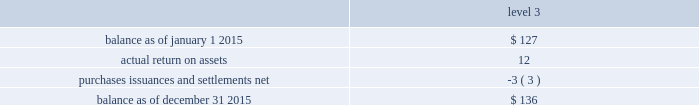The tables present a reconciliation of the beginning and ending balances of the fair value measurements using significant unobservable inputs ( level 3 ) for 2015 and 2014 , respectively: .
Purchases , issuances and settlements , net .
76 balance as of december 31 , 2014 .
$ 127 the company 2019s other postretirement benefit plans are partially funded and the assets are held under various trusts .
The investments and risk mitigation strategies for the plans are tailored specifically for each trust .
In setting new strategic asset mixes , consideration is given to the likelihood that the selected asset allocation will effectively fund the projected plan liabilities and the risk tolerance of the company .
The company periodically updates the long-term , strategic asset allocations and uses various analytics to determine the optimal asset allocation .
Considerations include plan liability characteristics , liquidity characteristics , funding requirements , expected rates of return and the distribution of returns .
In june 2012 , the company implemented a de-risking strategy for the medical bargaining trust within the plan to minimize volatility .
As part of the de-risking strategy , the company revised the asset allocations to increase the matching characteristics of assets relative to liabilities .
The initial de-risking asset allocation for the plan was 60% ( 60 % ) return-generating assets and 40% ( 40 % ) liability-driven assets .
The investment strategies and policies for the plan reflect a balance of liability driven and return-generating considerations .
The objective of minimizing the volatility of assets relative to liabilities is addressed primarily through asset 2014liability matching , asset diversification and hedging .
The fixed income target asset allocation matches the bond-like and long-dated nature of the postretirement liabilities .
Assets are broadly diversified within asset classes to achieve risk-adjusted returns that in total lower asset volatility relative to the liabilities .
The company assesses the investment strategy regularly to ensure actual allocations are in line with target allocations as appropriate .
Strategies to address the goal of ensuring sufficient assets to pay benefits include target allocations to a broad array of asset classes and , within asset classes strategies are employed to provide adequate returns , diversification and liquidity .
The assets of the company 2019s other trusts , within the other postretirement benefit plans , have been primarily invested in equities and fixed income funds .
The assets under the various other postretirement benefit trusts are invested differently based on the assets and liabilities of each trust .
The obligations of the other postretirement benefit plans are dominated by obligations for the medical bargaining trust .
Thirty-nine percent and four percent of the total postretirement plan benefit obligations are related to the medical non-bargaining and life insurance trusts , respectively .
Because expected benefit payments related to the benefit obligations are so far into the future , and the size of the medical non-bargaining and life insurance trusts 2019 obligations are large compared to each trusts 2019 assets , the investment strategy is to allocate a significant portion of the assets 2019 investment to equities , which the company believes will provide the highest long-term return and improve the funding ratio .
The company engages third party investment managers for all invested assets .
Managers are not permitted to invest outside of the asset class ( e.g .
Fixed income , equity , alternatives ) or strategy for which they have been appointed .
Investment management agreements and recurring performance and attribution analysis are used as tools to ensure investment managers invest solely within the investment strategy they have been provided .
Futures and options may be used to adjust portfolio duration to align with a plan 2019s targeted investment policy. .
What was the growth rate in the account balance 2015? 
Rationale: the growth rate of the account balance is the change from the begin to the end dividing the result by the begin balance
Computations: ((12 + -3) / 127)
Answer: 0.07087. The tables present a reconciliation of the beginning and ending balances of the fair value measurements using significant unobservable inputs ( level 3 ) for 2015 and 2014 , respectively: .
Purchases , issuances and settlements , net .
76 balance as of december 31 , 2014 .
$ 127 the company 2019s other postretirement benefit plans are partially funded and the assets are held under various trusts .
The investments and risk mitigation strategies for the plans are tailored specifically for each trust .
In setting new strategic asset mixes , consideration is given to the likelihood that the selected asset allocation will effectively fund the projected plan liabilities and the risk tolerance of the company .
The company periodically updates the long-term , strategic asset allocations and uses various analytics to determine the optimal asset allocation .
Considerations include plan liability characteristics , liquidity characteristics , funding requirements , expected rates of return and the distribution of returns .
In june 2012 , the company implemented a de-risking strategy for the medical bargaining trust within the plan to minimize volatility .
As part of the de-risking strategy , the company revised the asset allocations to increase the matching characteristics of assets relative to liabilities .
The initial de-risking asset allocation for the plan was 60% ( 60 % ) return-generating assets and 40% ( 40 % ) liability-driven assets .
The investment strategies and policies for the plan reflect a balance of liability driven and return-generating considerations .
The objective of minimizing the volatility of assets relative to liabilities is addressed primarily through asset 2014liability matching , asset diversification and hedging .
The fixed income target asset allocation matches the bond-like and long-dated nature of the postretirement liabilities .
Assets are broadly diversified within asset classes to achieve risk-adjusted returns that in total lower asset volatility relative to the liabilities .
The company assesses the investment strategy regularly to ensure actual allocations are in line with target allocations as appropriate .
Strategies to address the goal of ensuring sufficient assets to pay benefits include target allocations to a broad array of asset classes and , within asset classes strategies are employed to provide adequate returns , diversification and liquidity .
The assets of the company 2019s other trusts , within the other postretirement benefit plans , have been primarily invested in equities and fixed income funds .
The assets under the various other postretirement benefit trusts are invested differently based on the assets and liabilities of each trust .
The obligations of the other postretirement benefit plans are dominated by obligations for the medical bargaining trust .
Thirty-nine percent and four percent of the total postretirement plan benefit obligations are related to the medical non-bargaining and life insurance trusts , respectively .
Because expected benefit payments related to the benefit obligations are so far into the future , and the size of the medical non-bargaining and life insurance trusts 2019 obligations are large compared to each trusts 2019 assets , the investment strategy is to allocate a significant portion of the assets 2019 investment to equities , which the company believes will provide the highest long-term return and improve the funding ratio .
The company engages third party investment managers for all invested assets .
Managers are not permitted to invest outside of the asset class ( e.g .
Fixed income , equity , alternatives ) or strategy for which they have been appointed .
Investment management agreements and recurring performance and attribution analysis are used as tools to ensure investment managers invest solely within the investment strategy they have been provided .
Futures and options may be used to adjust portfolio duration to align with a plan 2019s targeted investment policy. .
What was the actual return on assets as a percentage of the 2015 ending balance? 
Computations: (12 / 136)
Answer: 0.08824. The tables present a reconciliation of the beginning and ending balances of the fair value measurements using significant unobservable inputs ( level 3 ) for 2015 and 2014 , respectively: .
Purchases , issuances and settlements , net .
76 balance as of december 31 , 2014 .
$ 127 the company 2019s other postretirement benefit plans are partially funded and the assets are held under various trusts .
The investments and risk mitigation strategies for the plans are tailored specifically for each trust .
In setting new strategic asset mixes , consideration is given to the likelihood that the selected asset allocation will effectively fund the projected plan liabilities and the risk tolerance of the company .
The company periodically updates the long-term , strategic asset allocations and uses various analytics to determine the optimal asset allocation .
Considerations include plan liability characteristics , liquidity characteristics , funding requirements , expected rates of return and the distribution of returns .
In june 2012 , the company implemented a de-risking strategy for the medical bargaining trust within the plan to minimize volatility .
As part of the de-risking strategy , the company revised the asset allocations to increase the matching characteristics of assets relative to liabilities .
The initial de-risking asset allocation for the plan was 60% ( 60 % ) return-generating assets and 40% ( 40 % ) liability-driven assets .
The investment strategies and policies for the plan reflect a balance of liability driven and return-generating considerations .
The objective of minimizing the volatility of assets relative to liabilities is addressed primarily through asset 2014liability matching , asset diversification and hedging .
The fixed income target asset allocation matches the bond-like and long-dated nature of the postretirement liabilities .
Assets are broadly diversified within asset classes to achieve risk-adjusted returns that in total lower asset volatility relative to the liabilities .
The company assesses the investment strategy regularly to ensure actual allocations are in line with target allocations as appropriate .
Strategies to address the goal of ensuring sufficient assets to pay benefits include target allocations to a broad array of asset classes and , within asset classes strategies are employed to provide adequate returns , diversification and liquidity .
The assets of the company 2019s other trusts , within the other postretirement benefit plans , have been primarily invested in equities and fixed income funds .
The assets under the various other postretirement benefit trusts are invested differently based on the assets and liabilities of each trust .
The obligations of the other postretirement benefit plans are dominated by obligations for the medical bargaining trust .
Thirty-nine percent and four percent of the total postretirement plan benefit obligations are related to the medical non-bargaining and life insurance trusts , respectively .
Because expected benefit payments related to the benefit obligations are so far into the future , and the size of the medical non-bargaining and life insurance trusts 2019 obligations are large compared to each trusts 2019 assets , the investment strategy is to allocate a significant portion of the assets 2019 investment to equities , which the company believes will provide the highest long-term return and improve the funding ratio .
The company engages third party investment managers for all invested assets .
Managers are not permitted to invest outside of the asset class ( e.g .
Fixed income , equity , alternatives ) or strategy for which they have been appointed .
Investment management agreements and recurring performance and attribution analysis are used as tools to ensure investment managers invest solely within the investment strategy they have been provided .
Futures and options may be used to adjust portfolio duration to align with a plan 2019s targeted investment policy. .
What was the percent of the return on assets as a percent of the account balance at december 31 , 2015? 
Rationale: the percent of the return on assets as part of the year end balance is the division of the return on assets by the end balance multiplied by 100
Computations: (12 / 136)
Answer: 0.08824. 